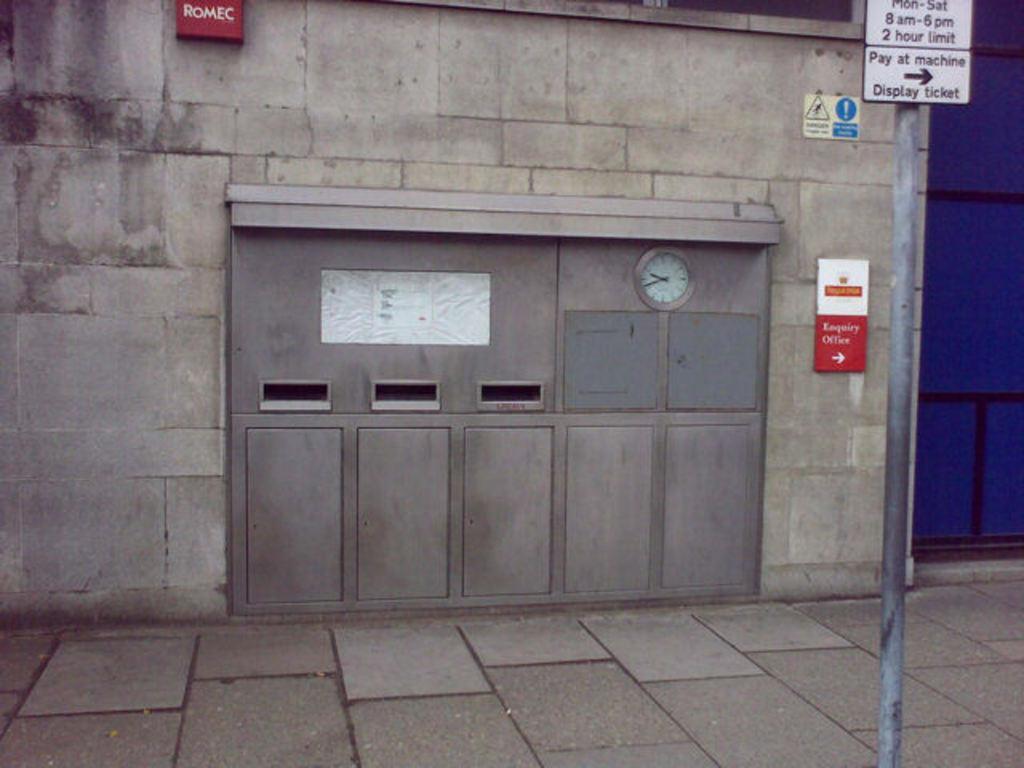Can you describe this image briefly? At the bottom of the image I can see the floor. On the right side there is a pole. At the top of it a board is attached. On the board I can see some text. In the background there is a wall to which a board, poster and a clock are attached. 